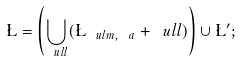<formula> <loc_0><loc_0><loc_500><loc_500>\L = \left ( \bigcup _ { \ u l { l } } ( \L _ { \ u l { m } , \ a } + \ u l { l } ) \right ) \cup \L ^ { \prime } ;</formula> 